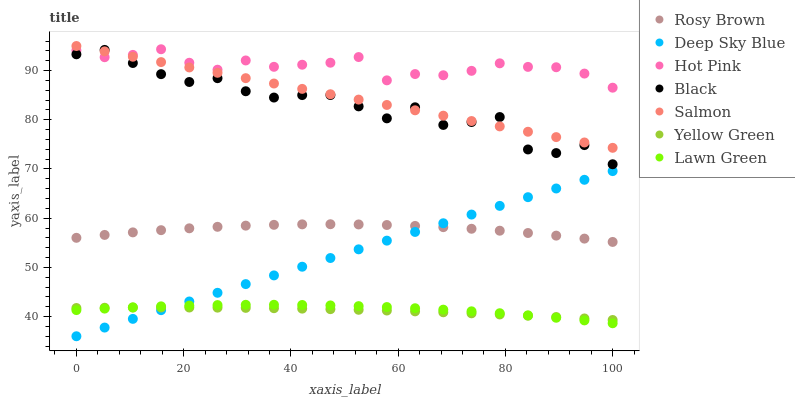Does Yellow Green have the minimum area under the curve?
Answer yes or no. Yes. Does Hot Pink have the maximum area under the curve?
Answer yes or no. Yes. Does Hot Pink have the minimum area under the curve?
Answer yes or no. No. Does Yellow Green have the maximum area under the curve?
Answer yes or no. No. Is Salmon the smoothest?
Answer yes or no. Yes. Is Black the roughest?
Answer yes or no. Yes. Is Hot Pink the smoothest?
Answer yes or no. No. Is Hot Pink the roughest?
Answer yes or no. No. Does Deep Sky Blue have the lowest value?
Answer yes or no. Yes. Does Yellow Green have the lowest value?
Answer yes or no. No. Does Salmon have the highest value?
Answer yes or no. Yes. Does Hot Pink have the highest value?
Answer yes or no. No. Is Lawn Green less than Salmon?
Answer yes or no. Yes. Is Black greater than Yellow Green?
Answer yes or no. Yes. Does Rosy Brown intersect Deep Sky Blue?
Answer yes or no. Yes. Is Rosy Brown less than Deep Sky Blue?
Answer yes or no. No. Is Rosy Brown greater than Deep Sky Blue?
Answer yes or no. No. Does Lawn Green intersect Salmon?
Answer yes or no. No. 